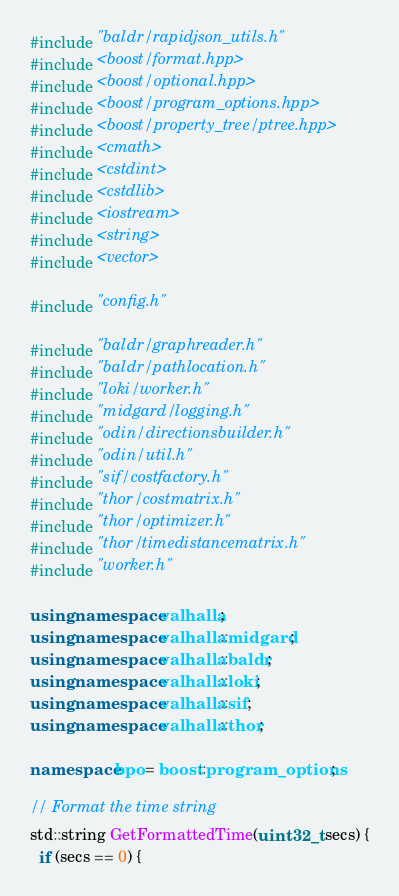<code> <loc_0><loc_0><loc_500><loc_500><_C++_>#include "baldr/rapidjson_utils.h"
#include <boost/format.hpp>
#include <boost/optional.hpp>
#include <boost/program_options.hpp>
#include <boost/property_tree/ptree.hpp>
#include <cmath>
#include <cstdint>
#include <cstdlib>
#include <iostream>
#include <string>
#include <vector>

#include "config.h"

#include "baldr/graphreader.h"
#include "baldr/pathlocation.h"
#include "loki/worker.h"
#include "midgard/logging.h"
#include "odin/directionsbuilder.h"
#include "odin/util.h"
#include "sif/costfactory.h"
#include "thor/costmatrix.h"
#include "thor/optimizer.h"
#include "thor/timedistancematrix.h"
#include "worker.h"

using namespace valhalla;
using namespace valhalla::midgard;
using namespace valhalla::baldr;
using namespace valhalla::loki;
using namespace valhalla::sif;
using namespace valhalla::thor;

namespace bpo = boost::program_options;

// Format the time string
std::string GetFormattedTime(uint32_t secs) {
  if (secs == 0) {</code> 